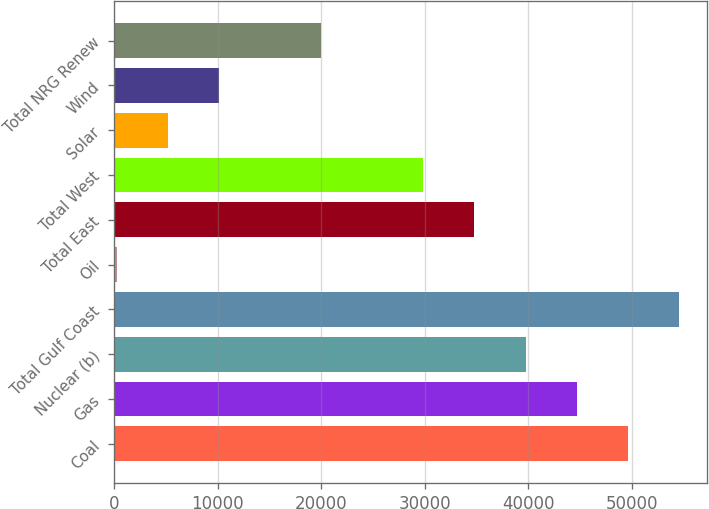Convert chart to OTSL. <chart><loc_0><loc_0><loc_500><loc_500><bar_chart><fcel>Coal<fcel>Gas<fcel>Nuclear (b)<fcel>Total Gulf Coast<fcel>Oil<fcel>Total East<fcel>Total West<fcel>Solar<fcel>Wind<fcel>Total NRG Renew<nl><fcel>49642<fcel>44701.1<fcel>39760.2<fcel>54582.9<fcel>233<fcel>34819.3<fcel>29878.4<fcel>5173.9<fcel>10114.8<fcel>19996.6<nl></chart> 